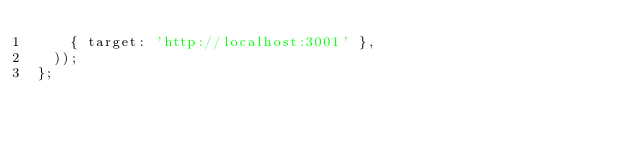Convert code to text. <code><loc_0><loc_0><loc_500><loc_500><_JavaScript_>		{ target: 'http://localhost:3001' },
	));
};
</code> 